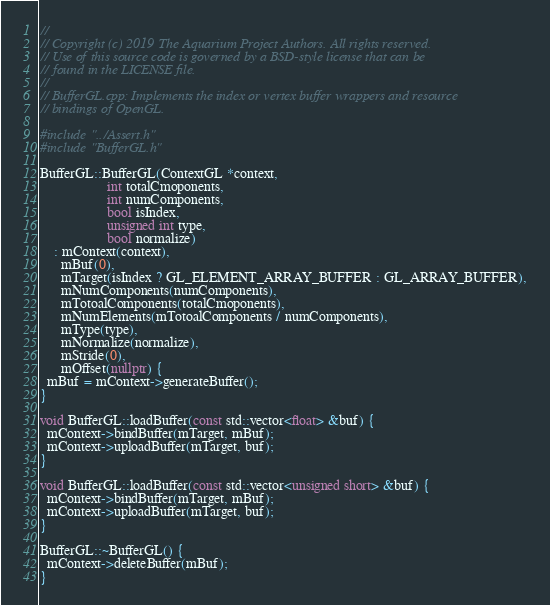Convert code to text. <code><loc_0><loc_0><loc_500><loc_500><_C++_>//
// Copyright (c) 2019 The Aquarium Project Authors. All rights reserved.
// Use of this source code is governed by a BSD-style license that can be
// found in the LICENSE file.
//
// BufferGL.cpp: Implements the index or vertex buffer wrappers and resource
// bindings of OpenGL.

#include "../Assert.h"
#include "BufferGL.h"

BufferGL::BufferGL(ContextGL *context,
                   int totalCmoponents,
                   int numComponents,
                   bool isIndex,
                   unsigned int type,
                   bool normalize)
    : mContext(context),
      mBuf(0),
      mTarget(isIndex ? GL_ELEMENT_ARRAY_BUFFER : GL_ARRAY_BUFFER),
      mNumComponents(numComponents),
      mTotoalComponents(totalCmoponents),
      mNumElements(mTotoalComponents / numComponents),
      mType(type),
      mNormalize(normalize),
      mStride(0),
      mOffset(nullptr) {
  mBuf = mContext->generateBuffer();
}

void BufferGL::loadBuffer(const std::vector<float> &buf) {
  mContext->bindBuffer(mTarget, mBuf);
  mContext->uploadBuffer(mTarget, buf);
}

void BufferGL::loadBuffer(const std::vector<unsigned short> &buf) {
  mContext->bindBuffer(mTarget, mBuf);
  mContext->uploadBuffer(mTarget, buf);
}

BufferGL::~BufferGL() {
  mContext->deleteBuffer(mBuf);
}
</code> 